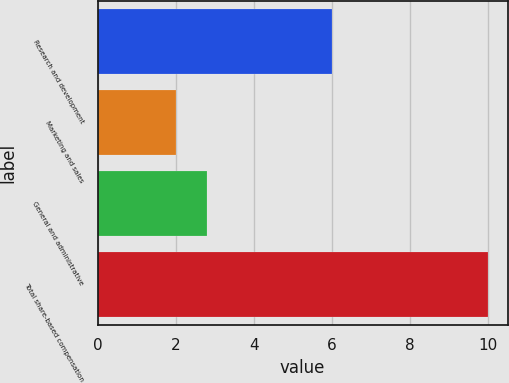<chart> <loc_0><loc_0><loc_500><loc_500><bar_chart><fcel>Research and development<fcel>Marketing and sales<fcel>General and administrative<fcel>Total share-based compensation<nl><fcel>6<fcel>2<fcel>2.8<fcel>10<nl></chart> 